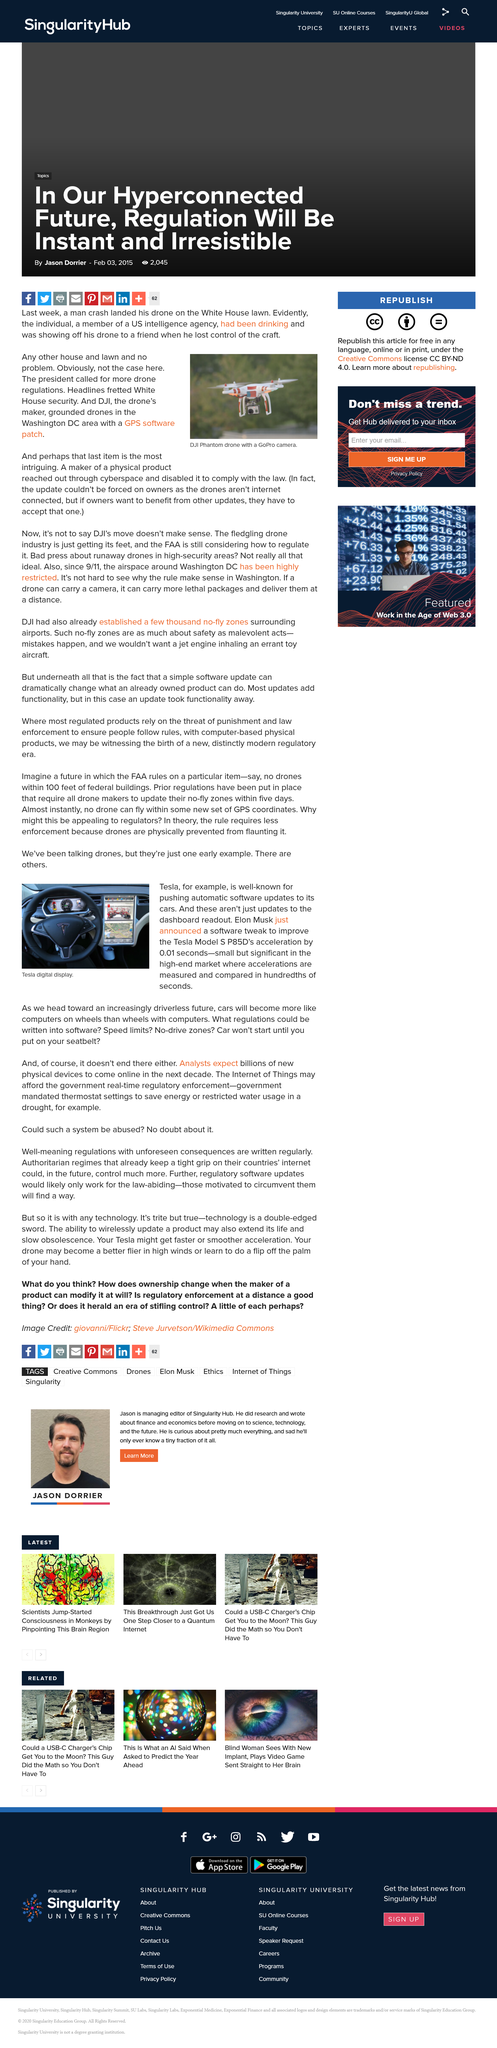Specify some key components in this picture. The man crash landed his drone on the White House lawn. The picture is a depiction of Tesla digital display. Elon Musk announced a software tweak that improved the acceleration of Tesla Model S P85Ds by 0.01 seconds. DJI grounded its drones with a GPS software patch in response to concerns about the safety and security of its products. The image features a DJI Phantom drone. 